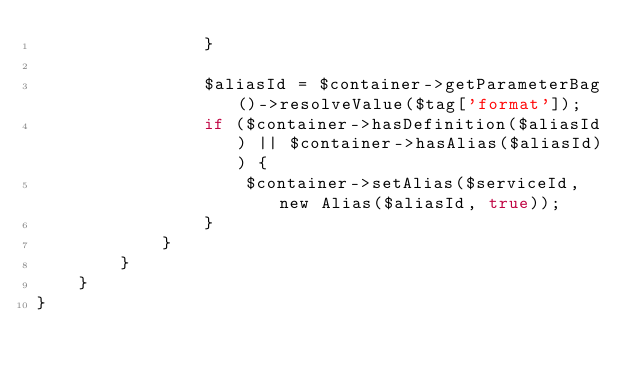Convert code to text. <code><loc_0><loc_0><loc_500><loc_500><_PHP_>                }

                $aliasId = $container->getParameterBag()->resolveValue($tag['format']);
                if ($container->hasDefinition($aliasId) || $container->hasAlias($aliasId)) {
                    $container->setAlias($serviceId, new Alias($aliasId, true));
                }
            }
        }
    }
}
</code> 